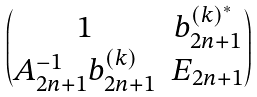Convert formula to latex. <formula><loc_0><loc_0><loc_500><loc_500>\begin{pmatrix} 1 & b _ { 2 n + 1 } ^ { ( k ) ^ { * } } \\ A _ { 2 n + 1 } ^ { - 1 } b _ { 2 n + 1 } ^ { ( k ) } & E _ { 2 n + 1 } \end{pmatrix}</formula> 